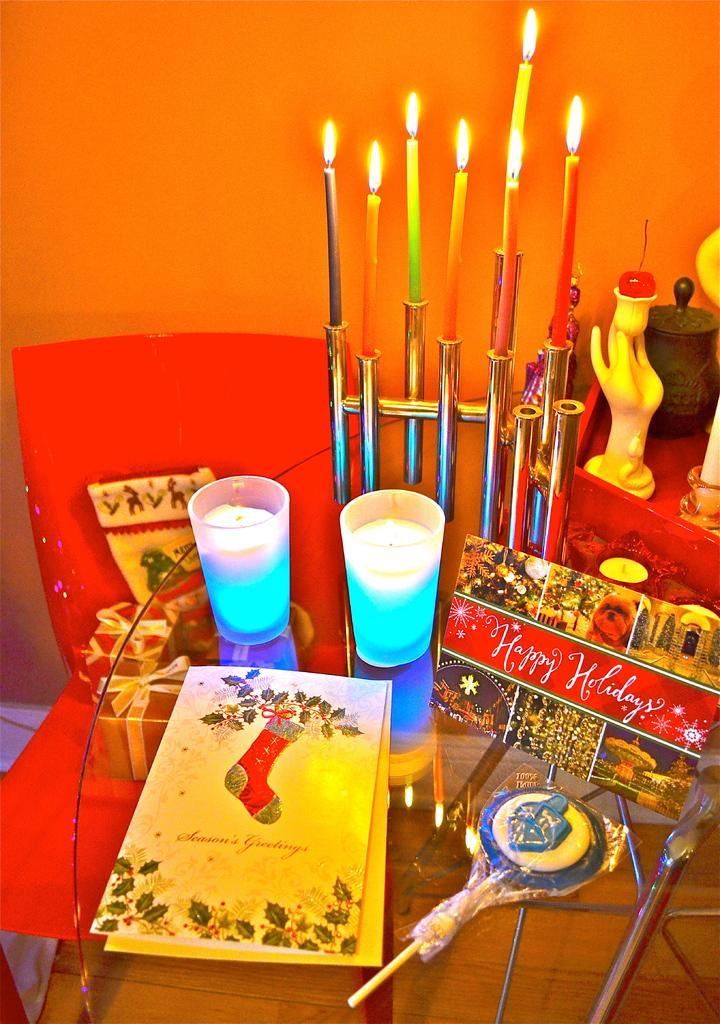How would you summarize this image in a sentence or two? In this picture there is a glass table. On the table there are greeting cards, candles, candle holder, sculpture and a lollipop. There are candles lightened and placed on the candle holder. Beside the table there is a chair and gift boxes are placed on it. In the background there is wall. 